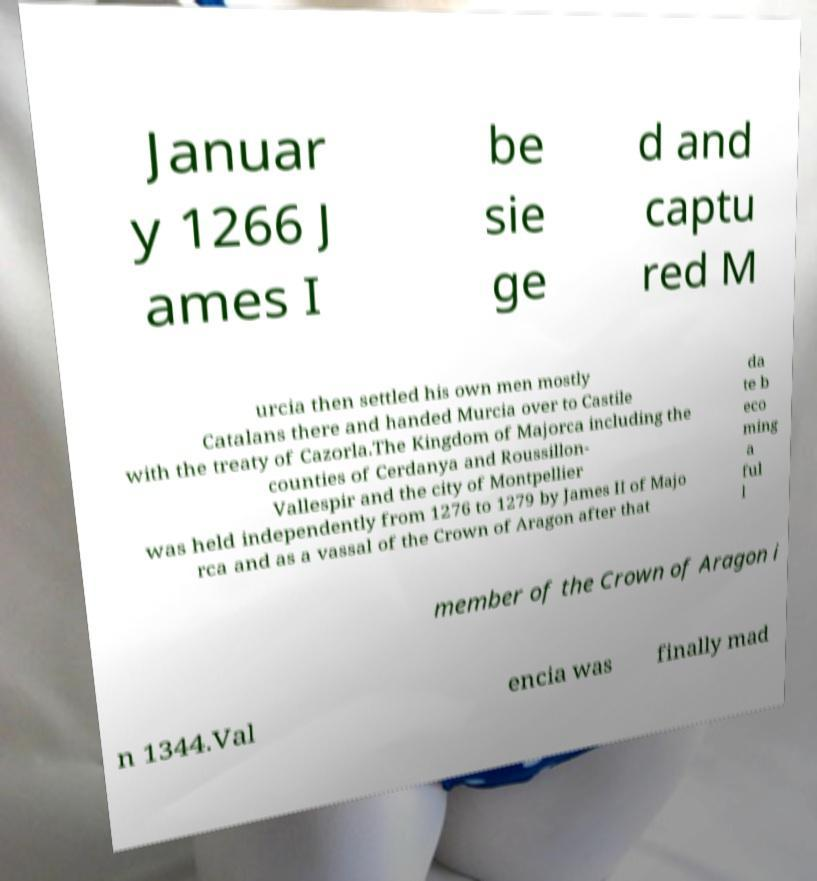Can you accurately transcribe the text from the provided image for me? Januar y 1266 J ames I be sie ge d and captu red M urcia then settled his own men mostly Catalans there and handed Murcia over to Castile with the treaty of Cazorla.The Kingdom of Majorca including the counties of Cerdanya and Roussillon- Vallespir and the city of Montpellier was held independently from 1276 to 1279 by James II of Majo rca and as a vassal of the Crown of Aragon after that da te b eco ming a ful l member of the Crown of Aragon i n 1344.Val encia was finally mad 